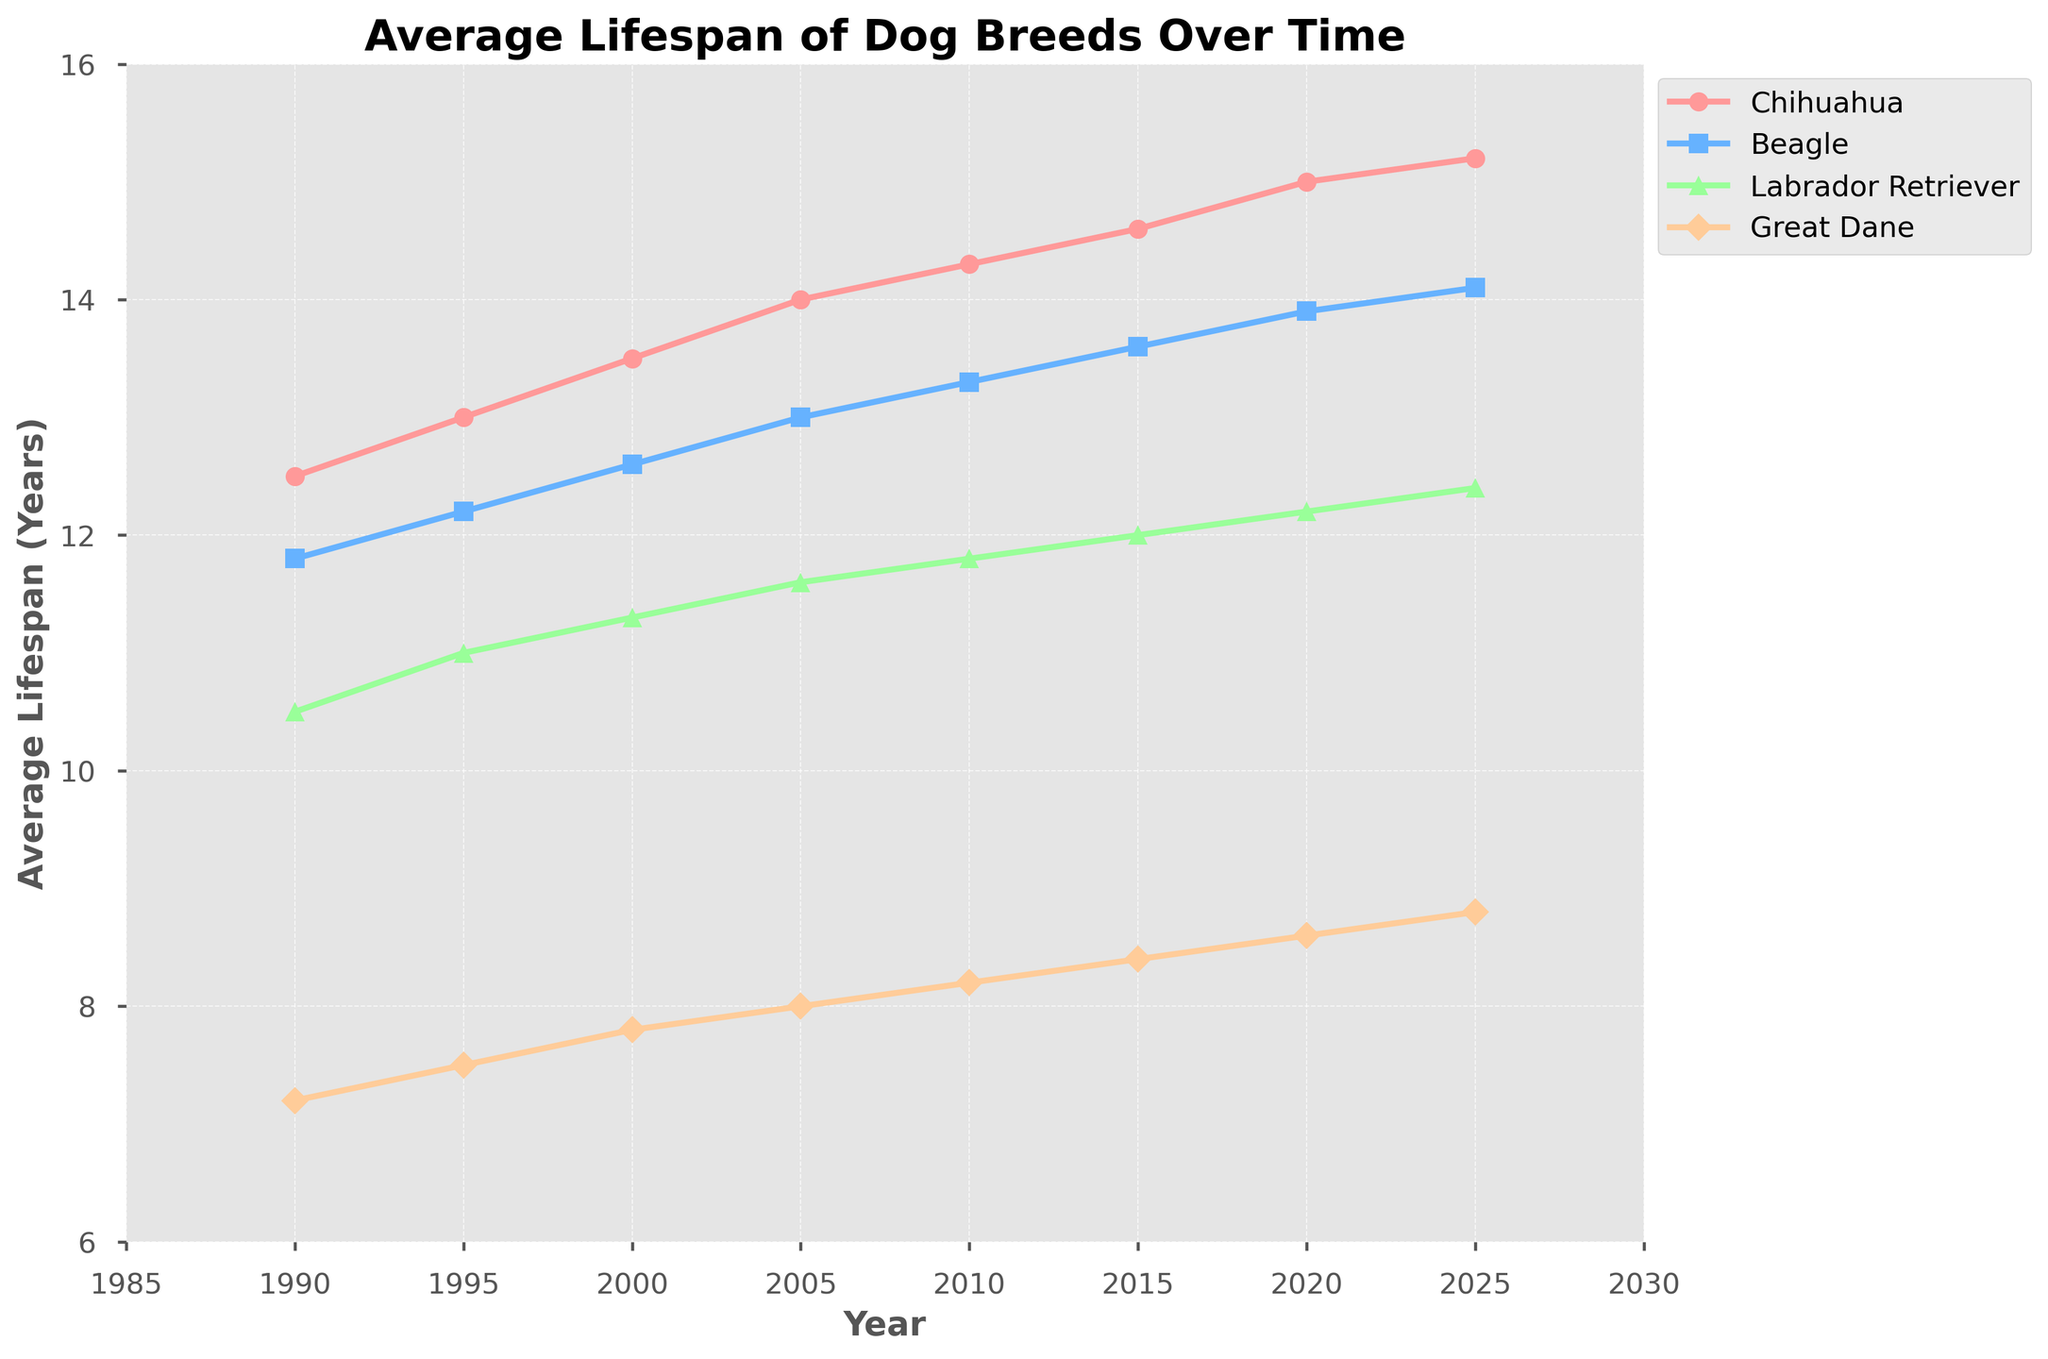What is the overall trend in the average lifespan of Chihuahuas from 1990 to 2025? The trend shows an upward movement as the average lifespan of Chihuahuas increases from 12.5 years in 1990 to 15.2 years in 2025.
Answer: Upward trend How does the average lifespan of Labrador Retrievers in 2010 compare to that of Great Danes in 2020? In 2010, the average lifespan of Labrador Retrievers is 11.8 years, while in 2020, the average lifespan of Great Danes is 8.6 years. Comparing these values, Labrador Retrievers have a higher average lifespan than Great Danes in their respective years.
Answer: Higher Which breed shows the smallest increase in average lifespan from 1990 to 2025? To determine this, we compute the increase for each breed:
Chihuahua: 15.2 - 12.5 = 2.7
Beagle: 14.1 - 11.8 = 2.3
Labrador Retriever: 12.4 - 10.5 = 1.9
Great Dane: 8.8 - 7.2 = 1.6
The smallest increase is observed for Great Danes.
Answer: Great Dane In what year does the average lifespan of Beagles first surpass 13 years? By examining the trend of Beagle lifespans, it first surpasses 13 years in 2005.
Answer: 2005 What was the average lifespan difference between Beagles and Great Danes in 2015? Beagle lifespan in 2015 is 13.6 years, and Great Dane lifespan in 2015 is 8.4 years. The difference is 13.6 - 8.4 = 5.2 years.
Answer: 5.2 years Which breed shows the most consistent increase in average lifespan over the years? By examining the plot and noting the smoothness and regularity of the lines, the Labrador Retriever shows a steady and consistent increase from 10.5 years in 1990 to 12.4 years in 2025.
Answer: Labrador Retriever What is the difference in the average lifespan between the smallest and largest breeds in 2025? The smallest breed is the Chihuahua with 15.2 years, and the largest breed is the Great Dane with 8.8 years in 2025. The difference is 15.2 - 8.8 = 6.4 years.
Answer: 6.4 years How have the lifespans of medium-sized Beagles changed from 1990 to 2005 compared to 2005 to 2020? From 1990 to 2005, the lifespan of Beagles increased from 11.8 to 13.0 years (1.2 years). From 2005 to 2020, it increased from 13.0 to 13.9 years (0.9 years). The increase was larger in the first period than in the second.
Answer: Larger increase from 1990 to 2005 